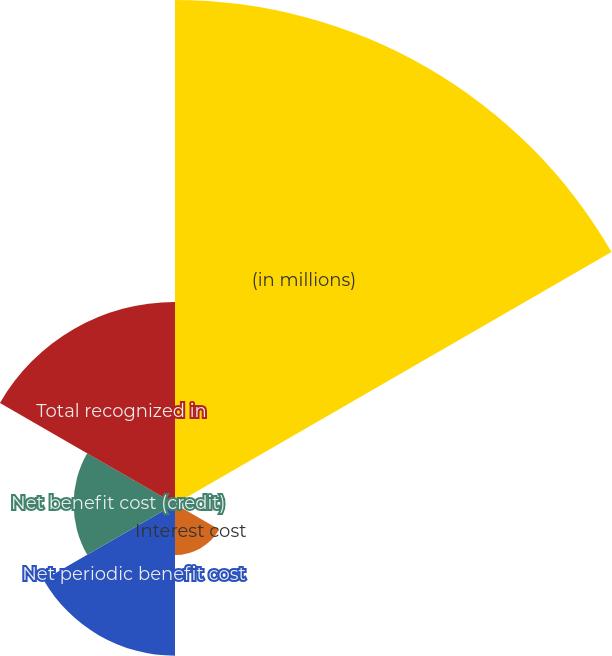Convert chart to OTSL. <chart><loc_0><loc_0><loc_500><loc_500><pie_chart><fcel>(in millions)<fcel>Service cost ^<fcel>Interest cost<fcel>Net periodic benefit cost<fcel>Net benefit cost (credit)<fcel>Total recognized in<nl><fcel>49.85%<fcel>0.07%<fcel>5.05%<fcel>15.01%<fcel>10.03%<fcel>19.99%<nl></chart> 